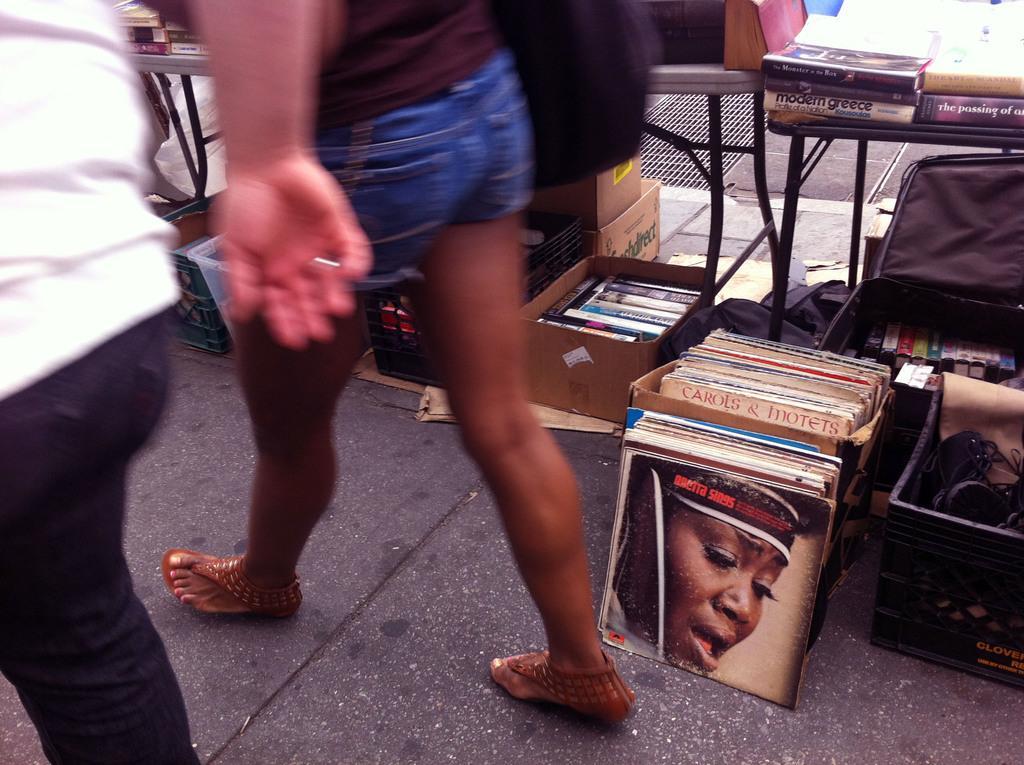Describe this image in one or two sentences. In this image we can see two people are walking on the pavement. In the background of the image, we can see the books, tables, cardboard boxes and bags. Behind the table, we can see a mesh. 